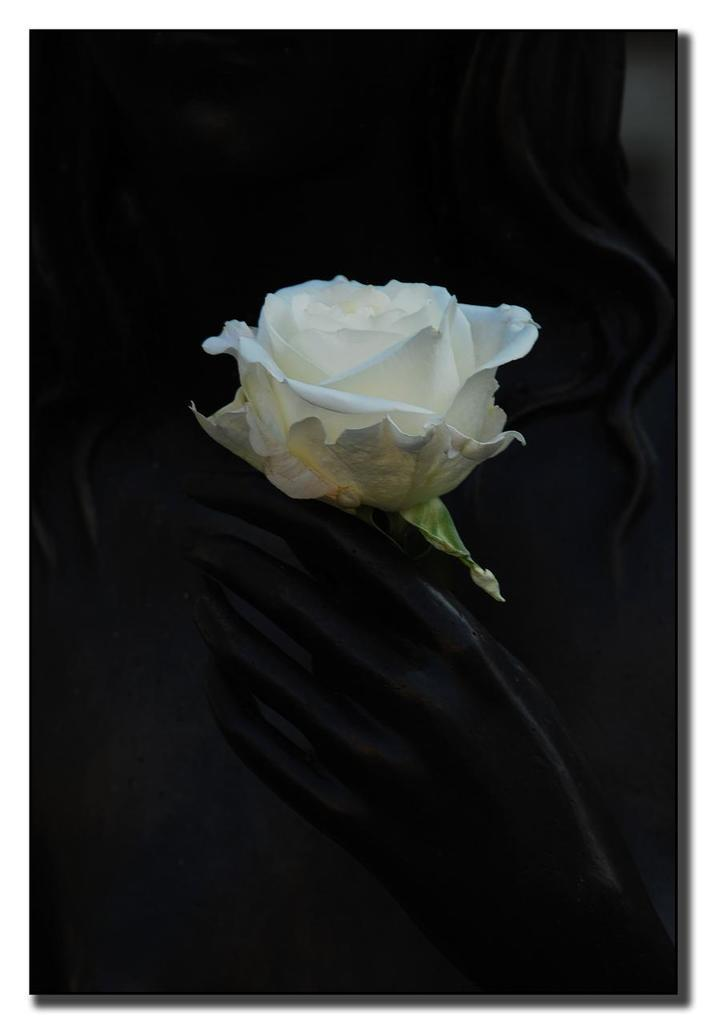What is the main subject of the image? There is a white color rose in the center of the image. What color is the background of the image? The background of the image is black. What type of current can be seen flowing through the rose in the image? There is no current present in the image; it is a still image of a white rose on a black background. Can you see any blood on the rose in the image? There is no blood present on the rose in the image; it is a white rose with no visible damage or discoloration. 